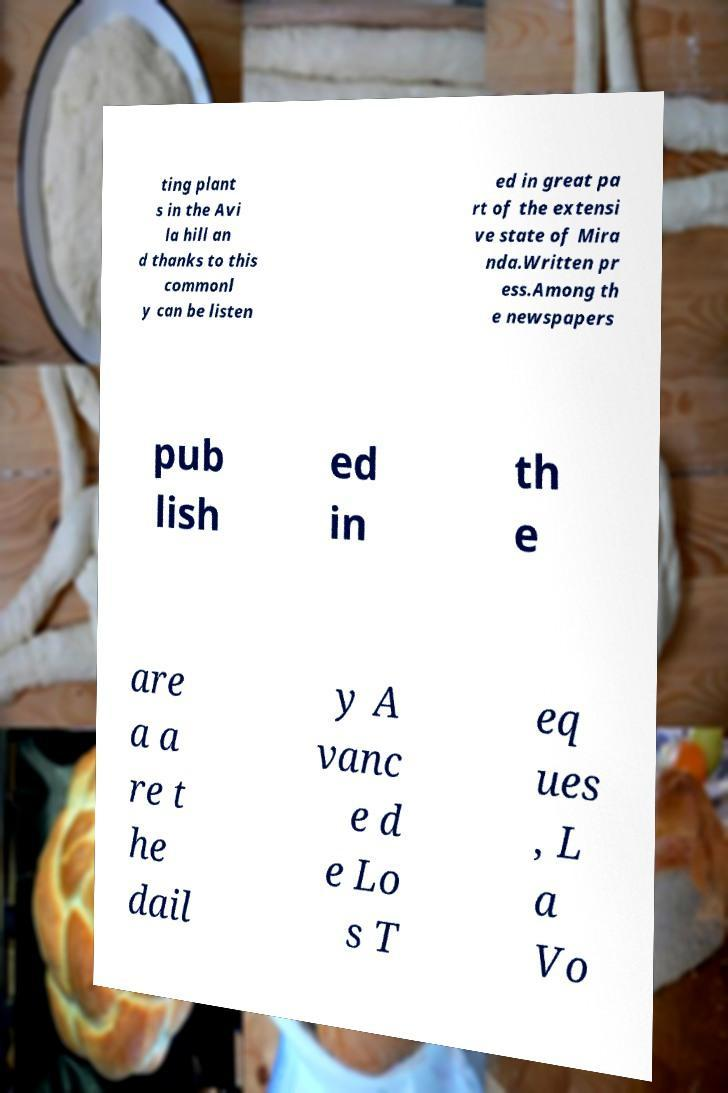Can you accurately transcribe the text from the provided image for me? ting plant s in the Avi la hill an d thanks to this commonl y can be listen ed in great pa rt of the extensi ve state of Mira nda.Written pr ess.Among th e newspapers pub lish ed in th e are a a re t he dail y A vanc e d e Lo s T eq ues , L a Vo 